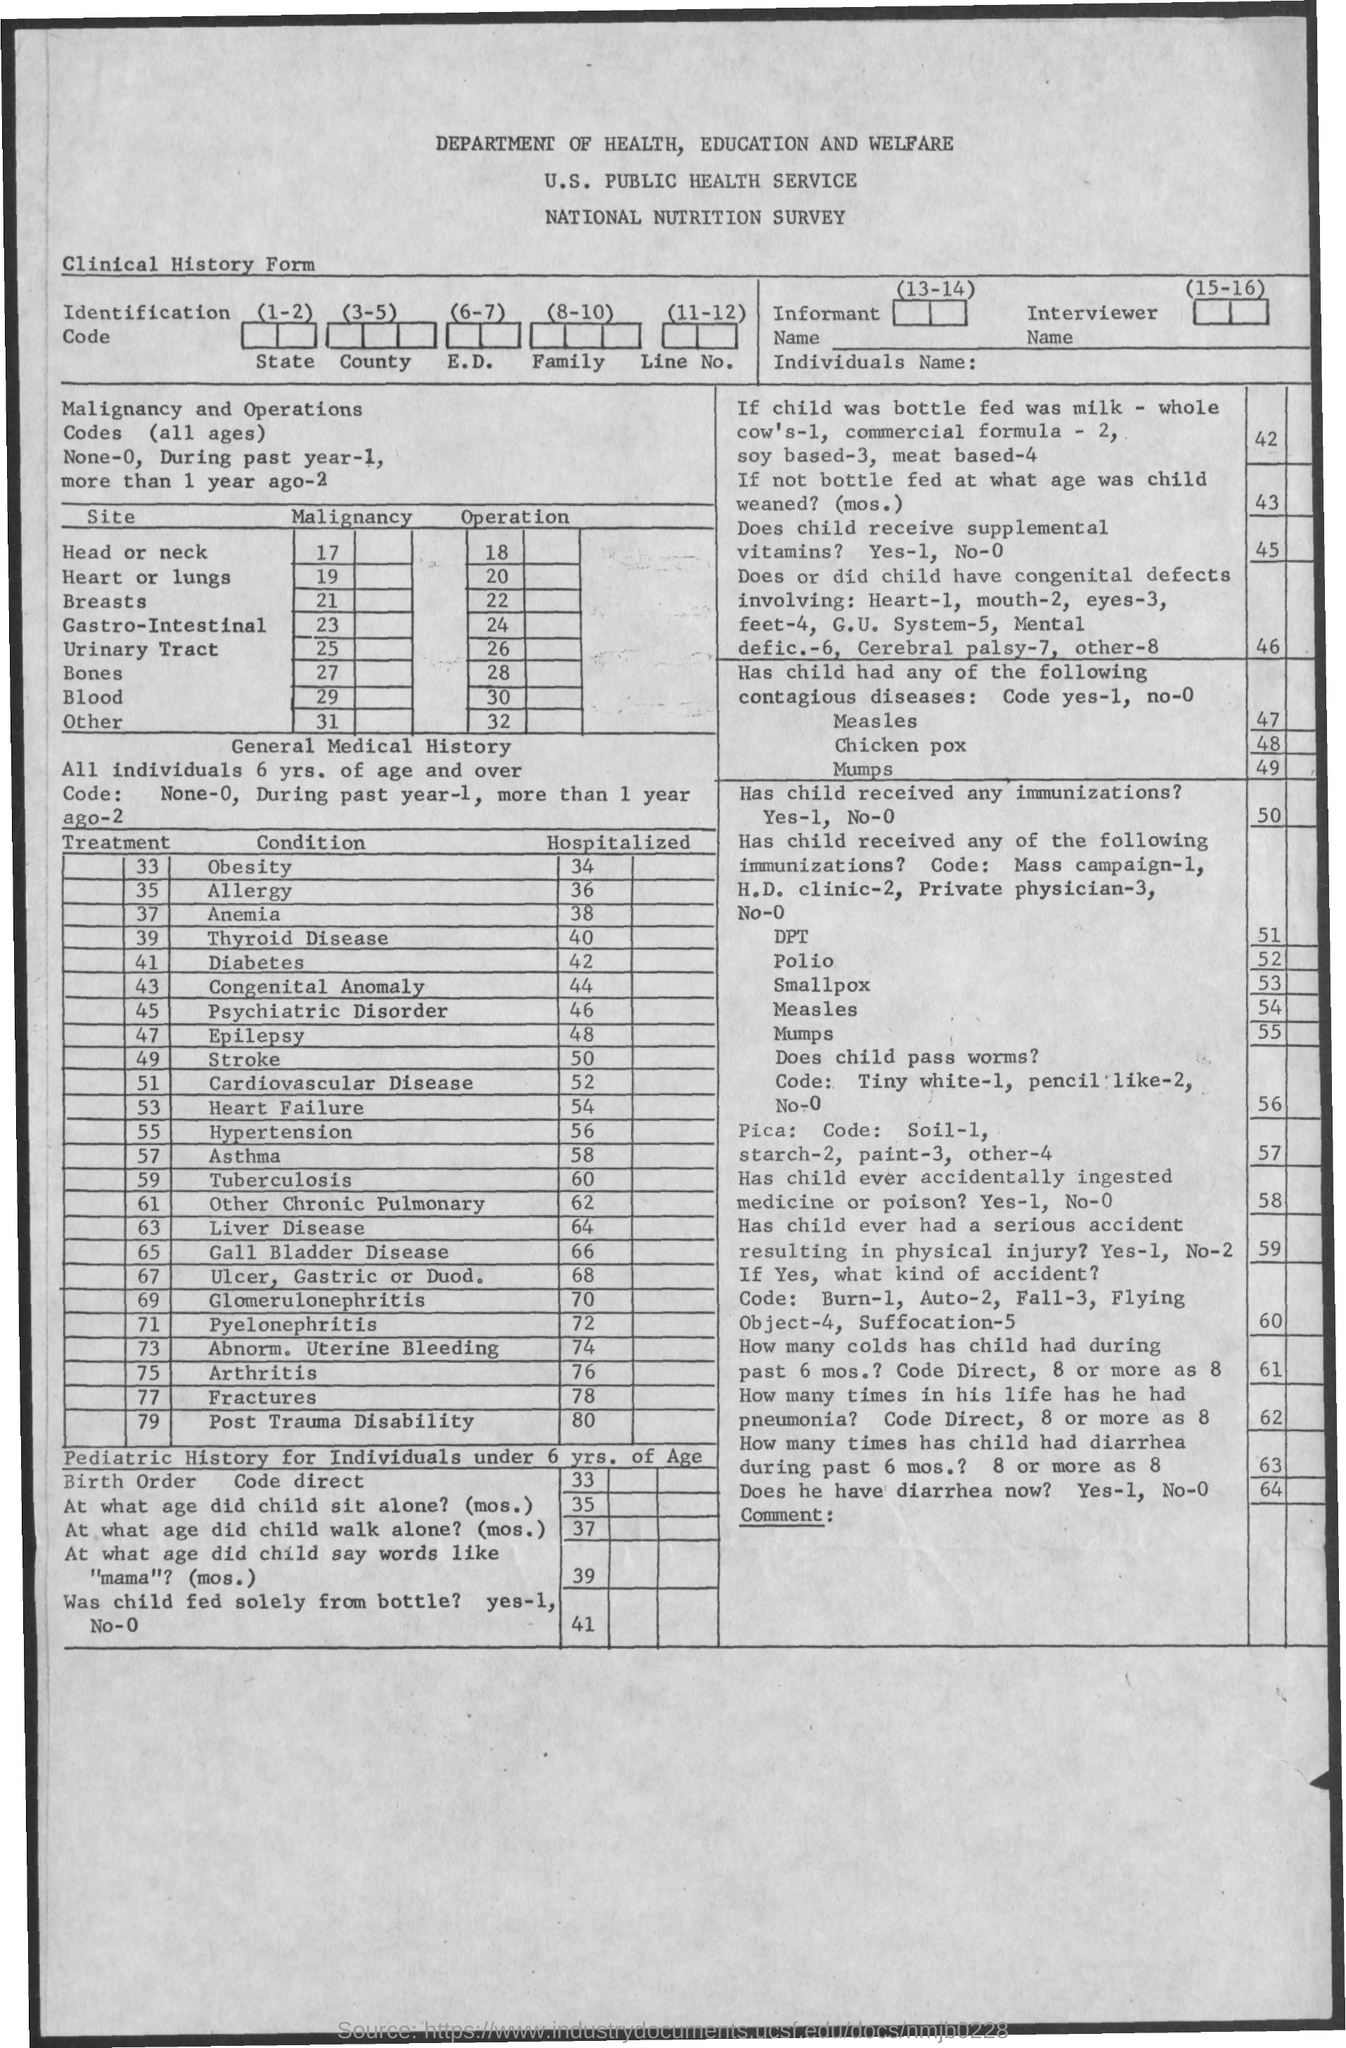Outline some significant characteristics in this image. Thirty-eight individuals are currently hospitalized due to anemia. It is estimated that 58 people are hospitalized for asthma. Sixty-four individuals are currently hospitalized for liver disease. The number of individuals hospitalized due to allergy is 36. It is estimated that approximately 40 people are hospitalized for thyroid disease each year. 